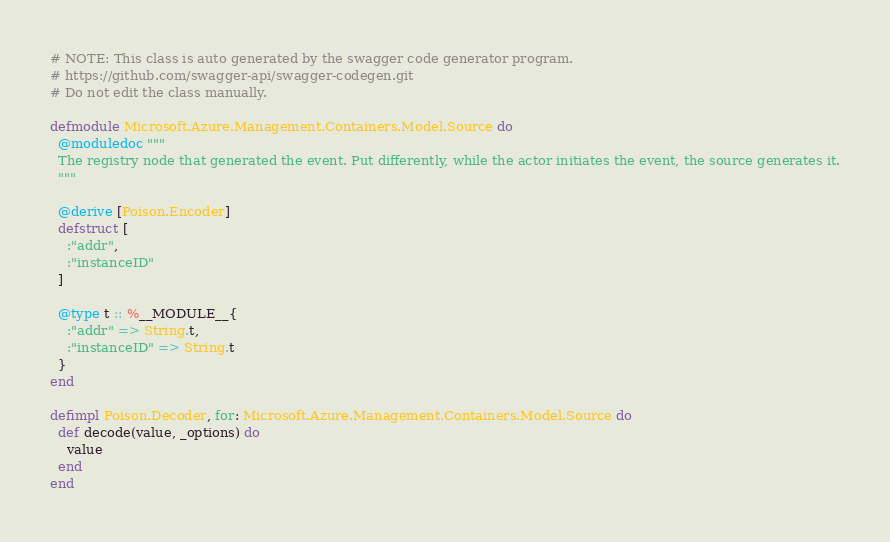<code> <loc_0><loc_0><loc_500><loc_500><_Elixir_># NOTE: This class is auto generated by the swagger code generator program.
# https://github.com/swagger-api/swagger-codegen.git
# Do not edit the class manually.

defmodule Microsoft.Azure.Management.Containers.Model.Source do
  @moduledoc """
  The registry node that generated the event. Put differently, while the actor initiates the event, the source generates it.
  """

  @derive [Poison.Encoder]
  defstruct [
    :"addr",
    :"instanceID"
  ]

  @type t :: %__MODULE__{
    :"addr" => String.t,
    :"instanceID" => String.t
  }
end

defimpl Poison.Decoder, for: Microsoft.Azure.Management.Containers.Model.Source do
  def decode(value, _options) do
    value
  end
end

</code> 